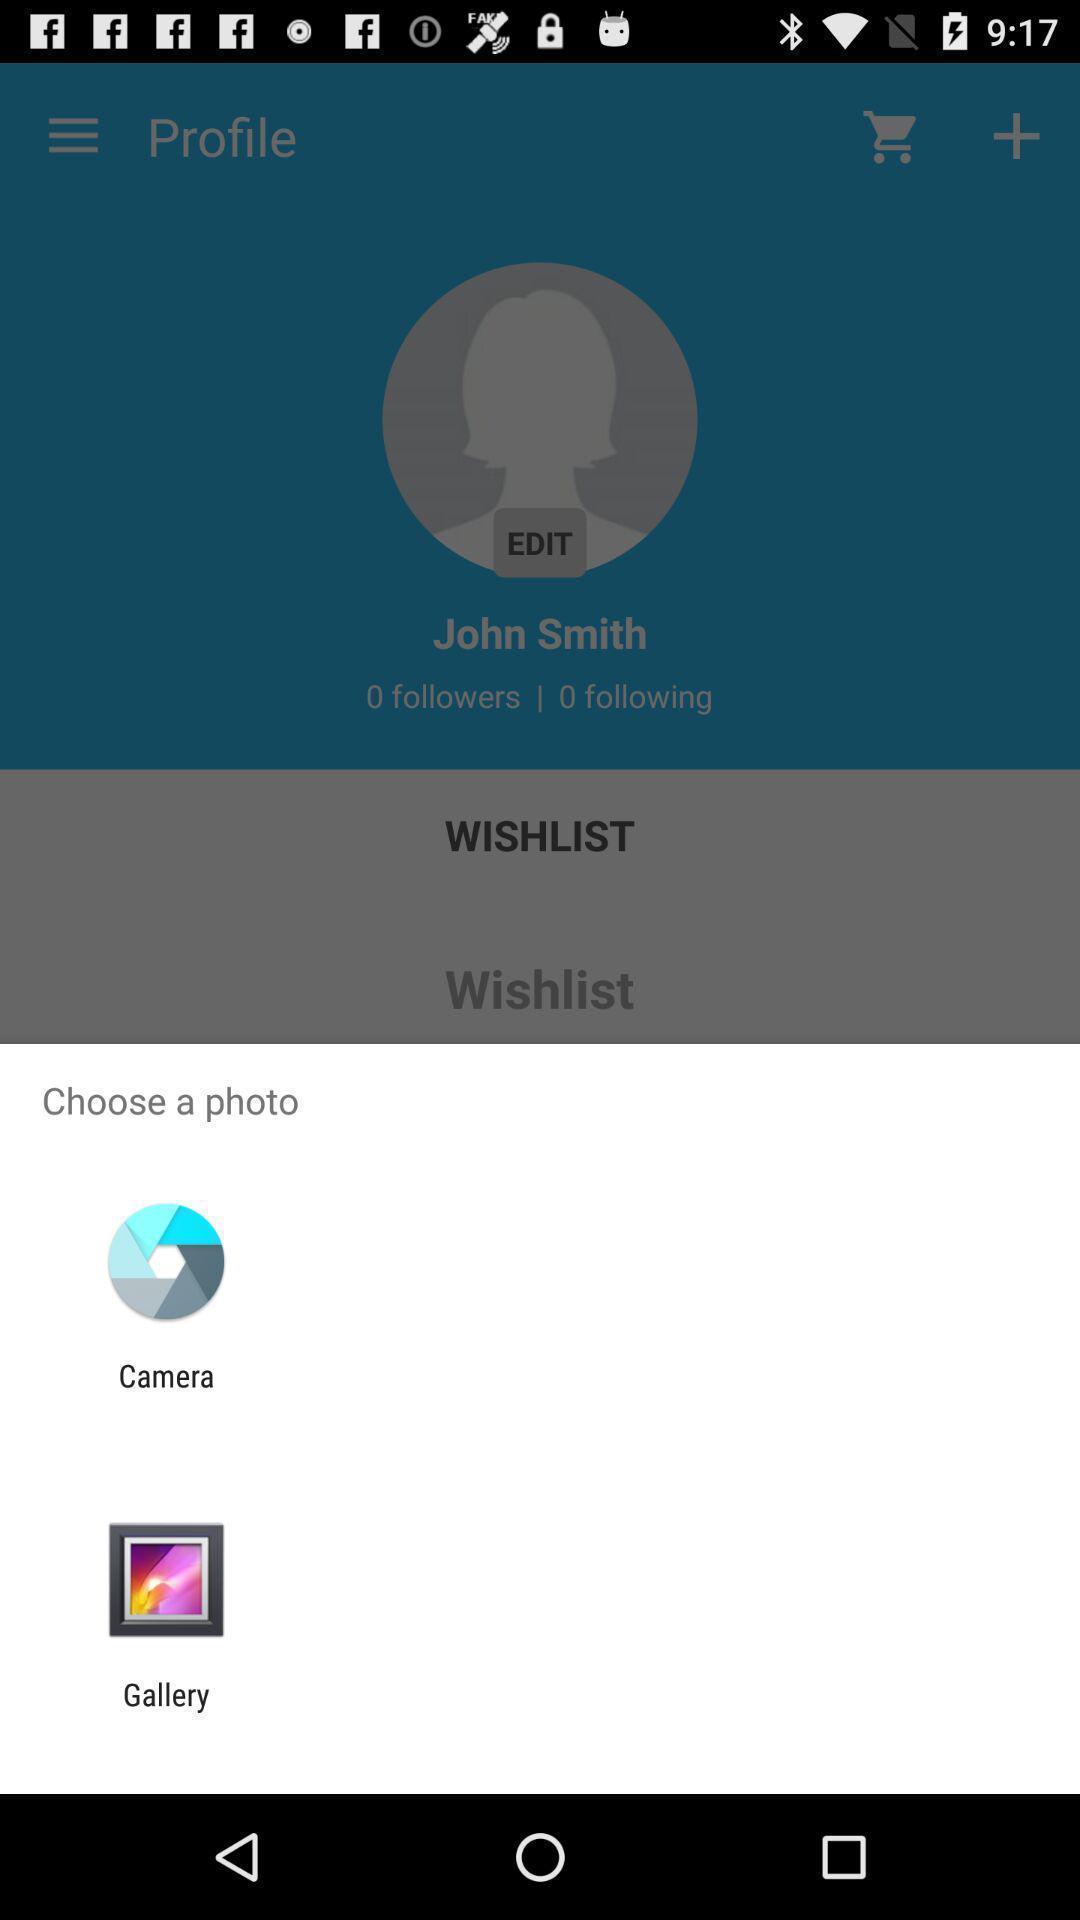Provide a textual representation of this image. Push up message asking to choose a photo. 